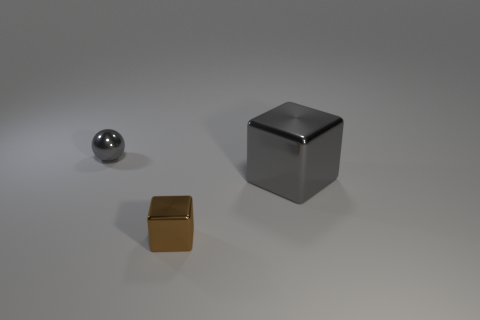Are there any other things that have the same size as the gray block?
Your response must be concise. No. What is the shape of the brown object?
Keep it short and to the point. Cube. The object in front of the gray thing that is in front of the shiny object to the left of the small brown cube is made of what material?
Your response must be concise. Metal. Is the number of things that are on the left side of the tiny gray shiny ball greater than the number of tiny brown metal things?
Provide a short and direct response. No. What material is the thing that is the same size as the metallic ball?
Keep it short and to the point. Metal. Are there any other gray spheres of the same size as the metal sphere?
Your response must be concise. No. What is the size of the gray thing that is to the right of the small gray sphere?
Provide a succinct answer. Large. How big is the brown metal thing?
Your answer should be very brief. Small. How many cylinders are blue shiny things or small gray things?
Ensure brevity in your answer.  0. What size is the gray ball that is the same material as the brown thing?
Your response must be concise. Small. 